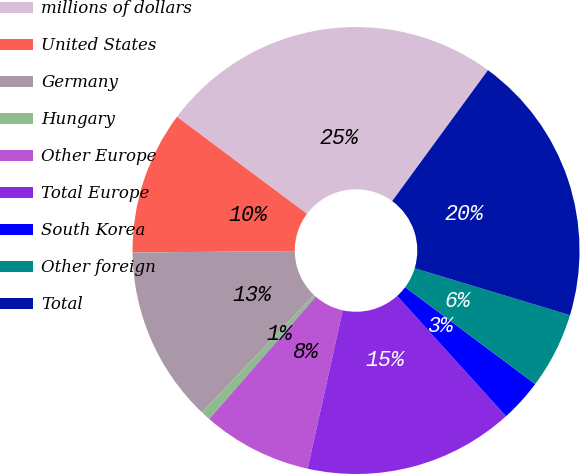<chart> <loc_0><loc_0><loc_500><loc_500><pie_chart><fcel>millions of dollars<fcel>United States<fcel>Germany<fcel>Hungary<fcel>Other Europe<fcel>Total Europe<fcel>South Korea<fcel>Other foreign<fcel>Total<nl><fcel>24.84%<fcel>10.35%<fcel>12.76%<fcel>0.69%<fcel>7.93%<fcel>15.18%<fcel>3.1%<fcel>5.52%<fcel>19.62%<nl></chart> 